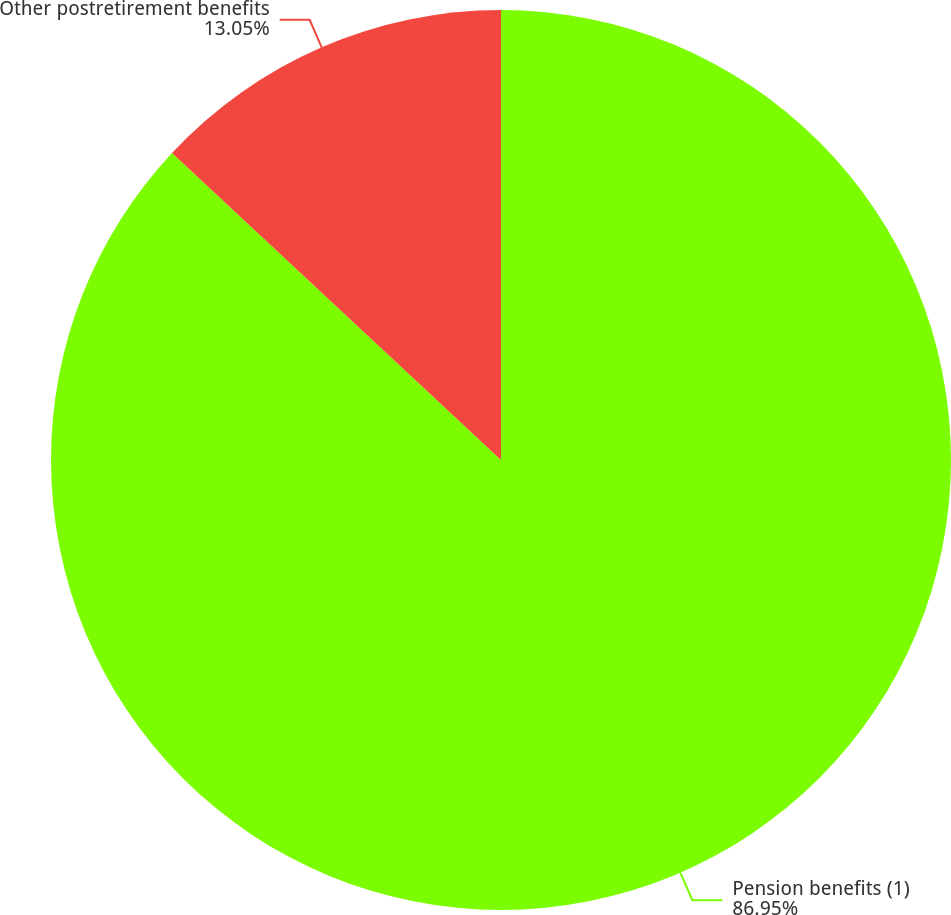<chart> <loc_0><loc_0><loc_500><loc_500><pie_chart><fcel>Pension benefits (1)<fcel>Other postretirement benefits<nl><fcel>86.95%<fcel>13.05%<nl></chart> 